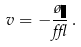<formula> <loc_0><loc_0><loc_500><loc_500>v = - \frac { \tau \eta } { \epsilon } \, .</formula> 